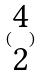<formula> <loc_0><loc_0><loc_500><loc_500>( \begin{matrix} 4 \\ 2 \end{matrix} )</formula> 